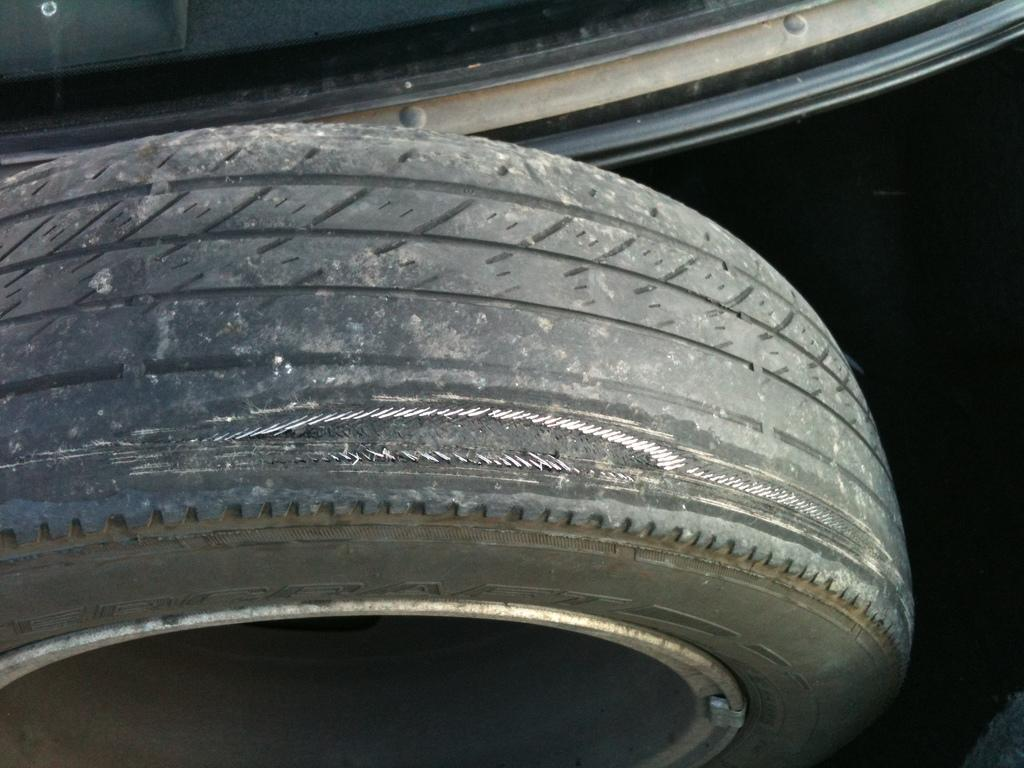What object can be seen in the image? There is a tyre in the image. How many legs does the tyre have in the image? Tyres do not have legs, as they are inanimate objects. 